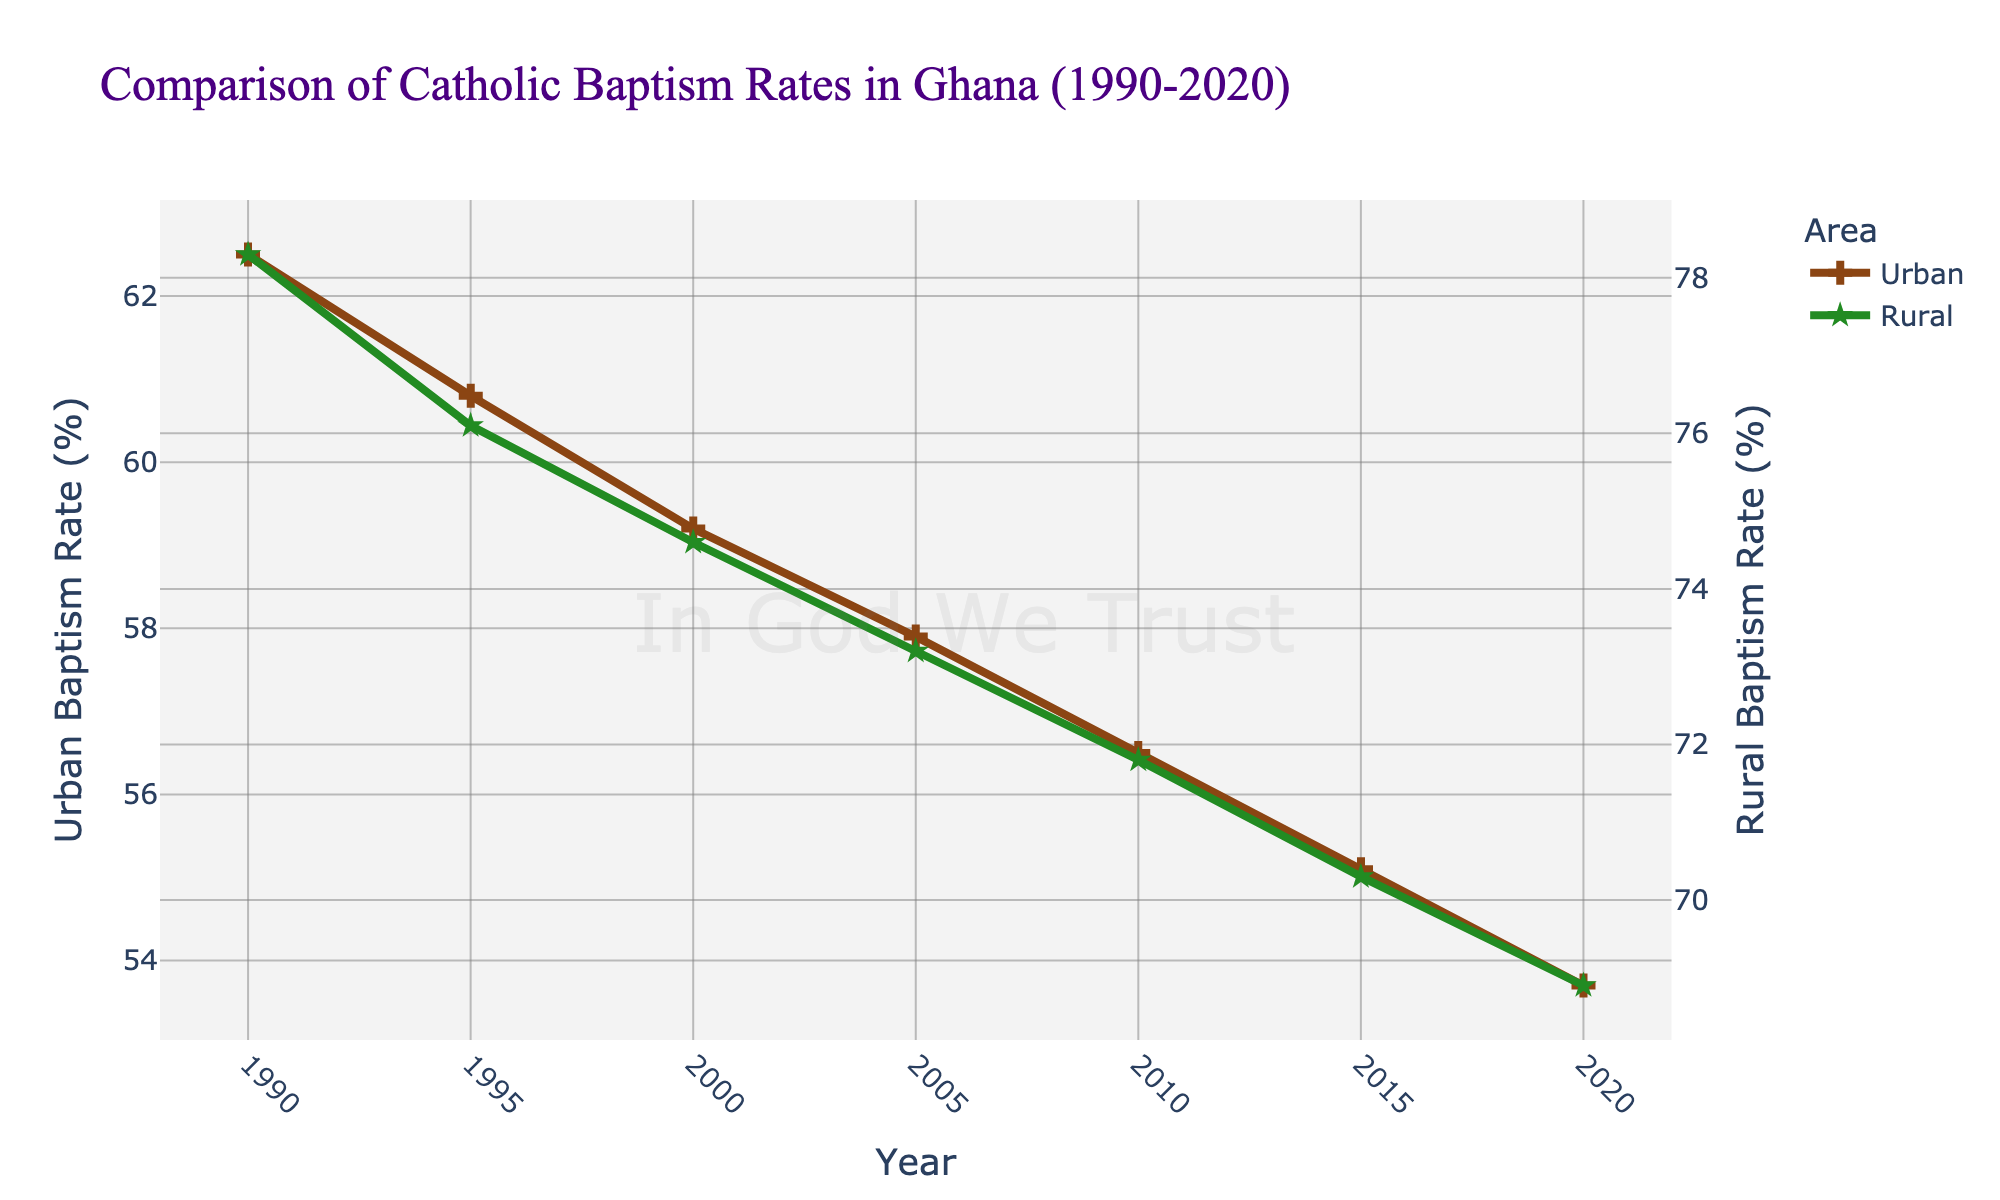what is the trend of the urban baptism rate over the years 1990 to 2020? To observe the trend, we look at the values of the urban baptism rate from 1990 to 2020. The values decline from 62.5 in 1990 to 53.7 in 2020, showing a general decreasing trend.
Answer: Decreasing How do the urban and rural baptism rates compare in the year 2000? In the year 2000, the urban baptism rate is 59.2%, and the rural baptism rate is 74.6%. Comparing these percentages, the rural rate is higher than the urban rate.
Answer: Rural is higher By how much did the rural baptism rate decrease from 1990 to 2020? The rural baptism rate in 1990 is 78.3%, and in 2020 it is 68.9%. The decrease can be calculated as 78.3 - 68.9 = 9.4%.
Answer: 9.4% Which area, urban or rural, shows a steeper decline in baptism rates over the thirty-year period? To determine the steeper decline, we calculate the rate of change. For urban: 62.5 (1990) to 53.7 (2020), a decrease of 8.8%. For rural: 78.3 (1990) to 68.9 (2020), a decrease of 9.4%. Rural shows a steeper decline.
Answer: Rural On the figure, what visual element distinguishes urban rate data from rural rate data? Urban data points are marked with crosses and have a brown line, while rural data points are marked with stars and have a green line.
Answer: Markers and colors What is the average baptism rate in urban areas over the three decades? We sum all the urban rates and then divide by the number of data points: (62.5 + 60.8 + 59.2 + 57.9 + 56.5 + 55.1 + 53.7) / 7 = 57.94%.
Answer: 57.94% In which decade does the urban baptism rate show the smallest decrease? By looking at the declines: 1990-1995 (1.7), 1995-2000 (1.6), 2000-2005 (1.3), 2005-2010 (1.4), 2010-2015 (1.4), 2015-2020 (1.4). The smallest decrease is observed in the decade 2000-2005.
Answer: 2000-2005 Is the rural baptism rate in 2020 higher or lower than the urban baptism rate in 1990? The rural baptism rate in 2020 is 68.9%, and the urban baptism rate in 1990 is 62.5%. Comparing these values, the rural rate in 2020 is higher.
Answer: Higher What color is used to represent the rural baptism rate on the plot? The rural baptism rate is represented by a green line on the plot.
Answer: Green 